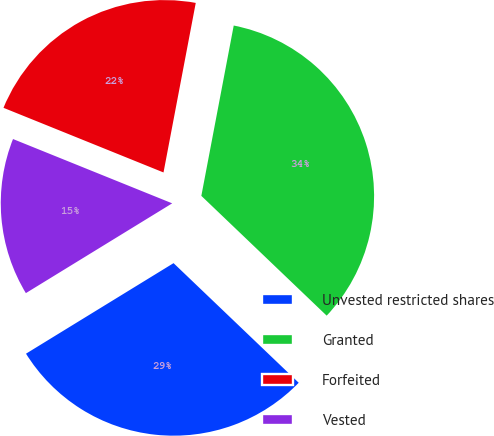<chart> <loc_0><loc_0><loc_500><loc_500><pie_chart><fcel>Unvested restricted shares<fcel>Granted<fcel>Forfeited<fcel>Vested<nl><fcel>29.1%<fcel>34.15%<fcel>21.88%<fcel>14.87%<nl></chart> 